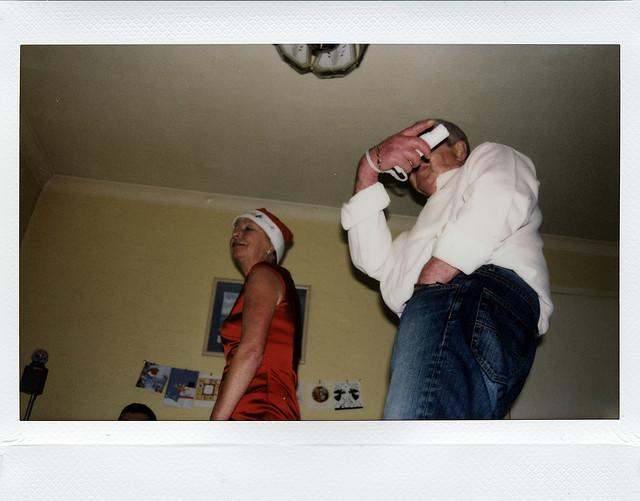What is the woman wearing on her head? santa hat 